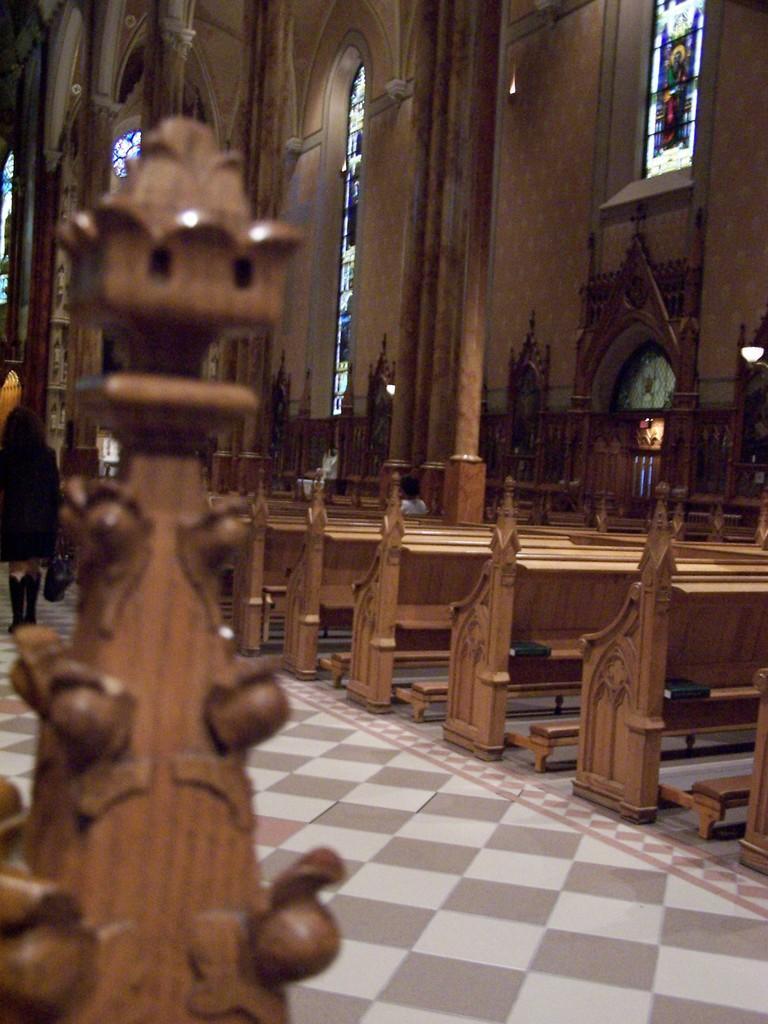In one or two sentences, can you explain what this image depicts? In this image I can see there are sitting benches, it looks like an inside part of a church. 